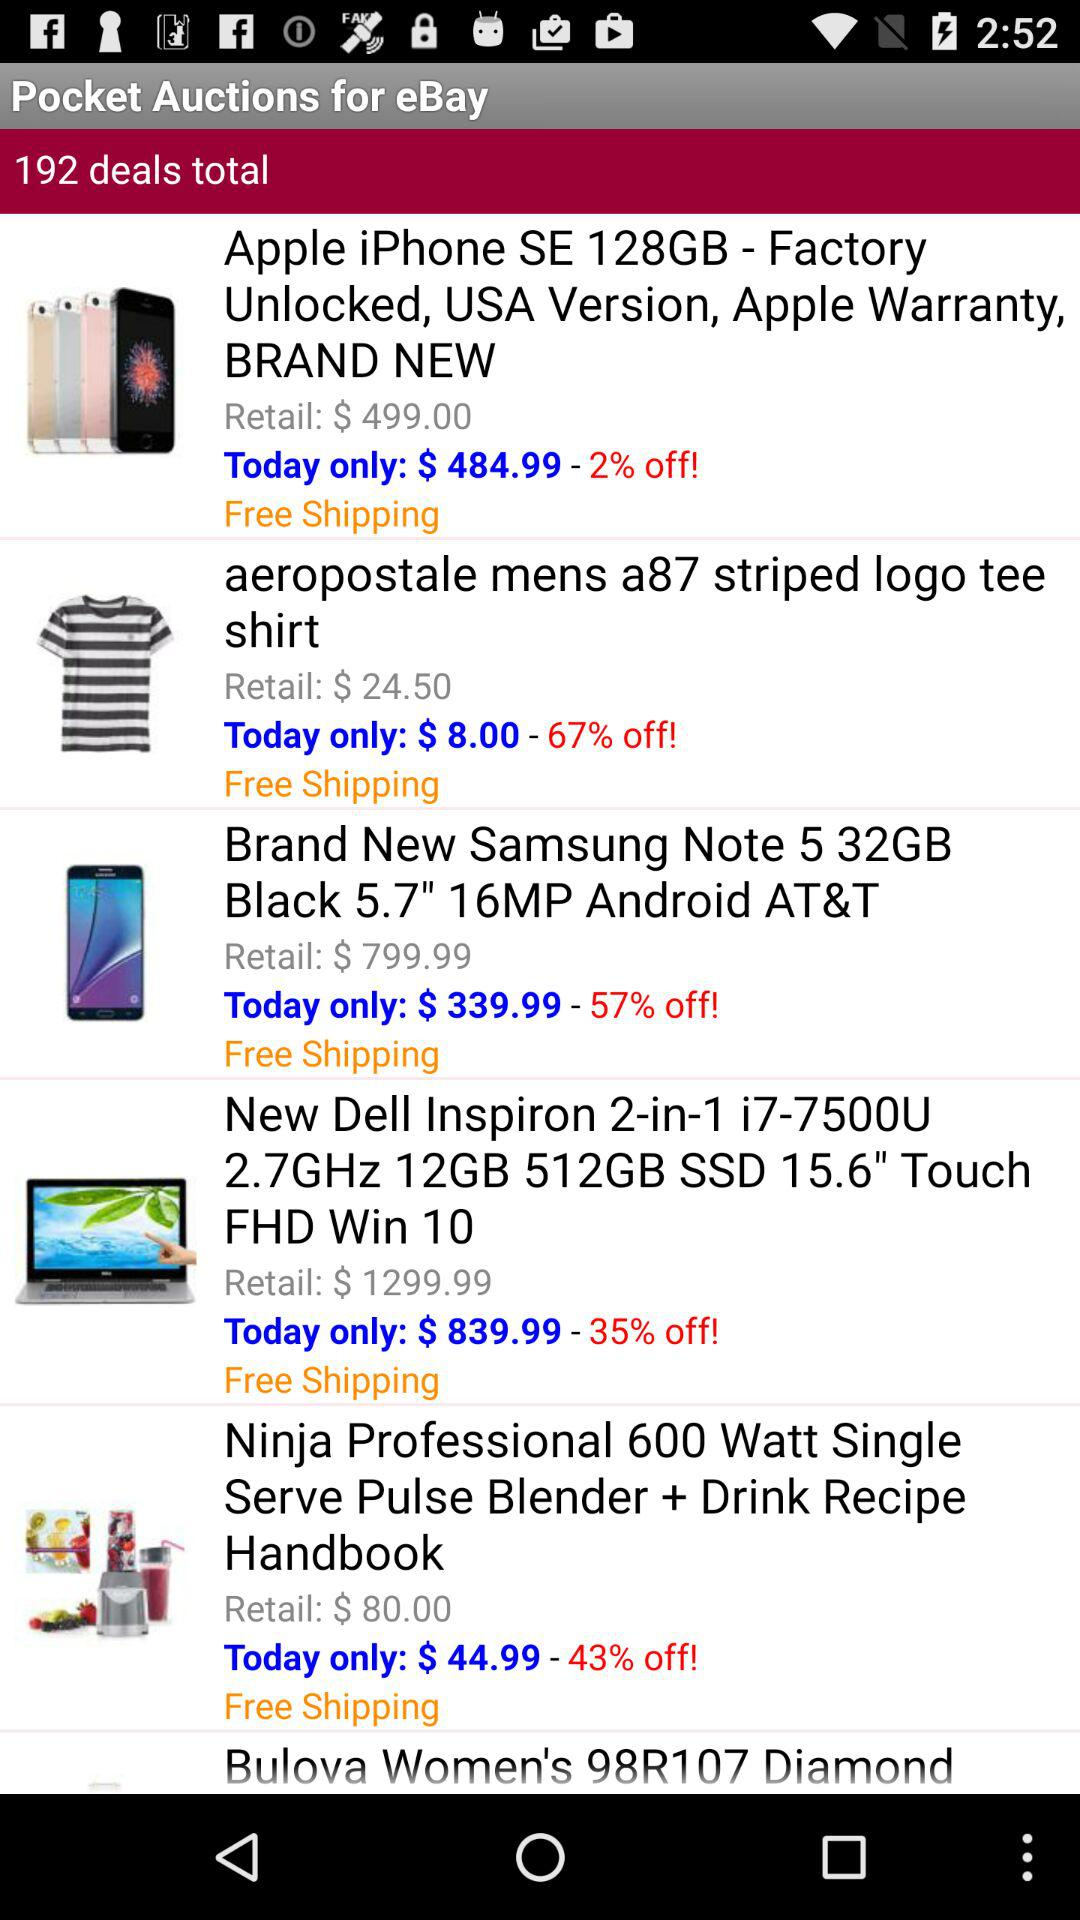How much is the retail price of the "aeropostale mens a87 striped logo tee shirt"? The retail price is $24.50. 